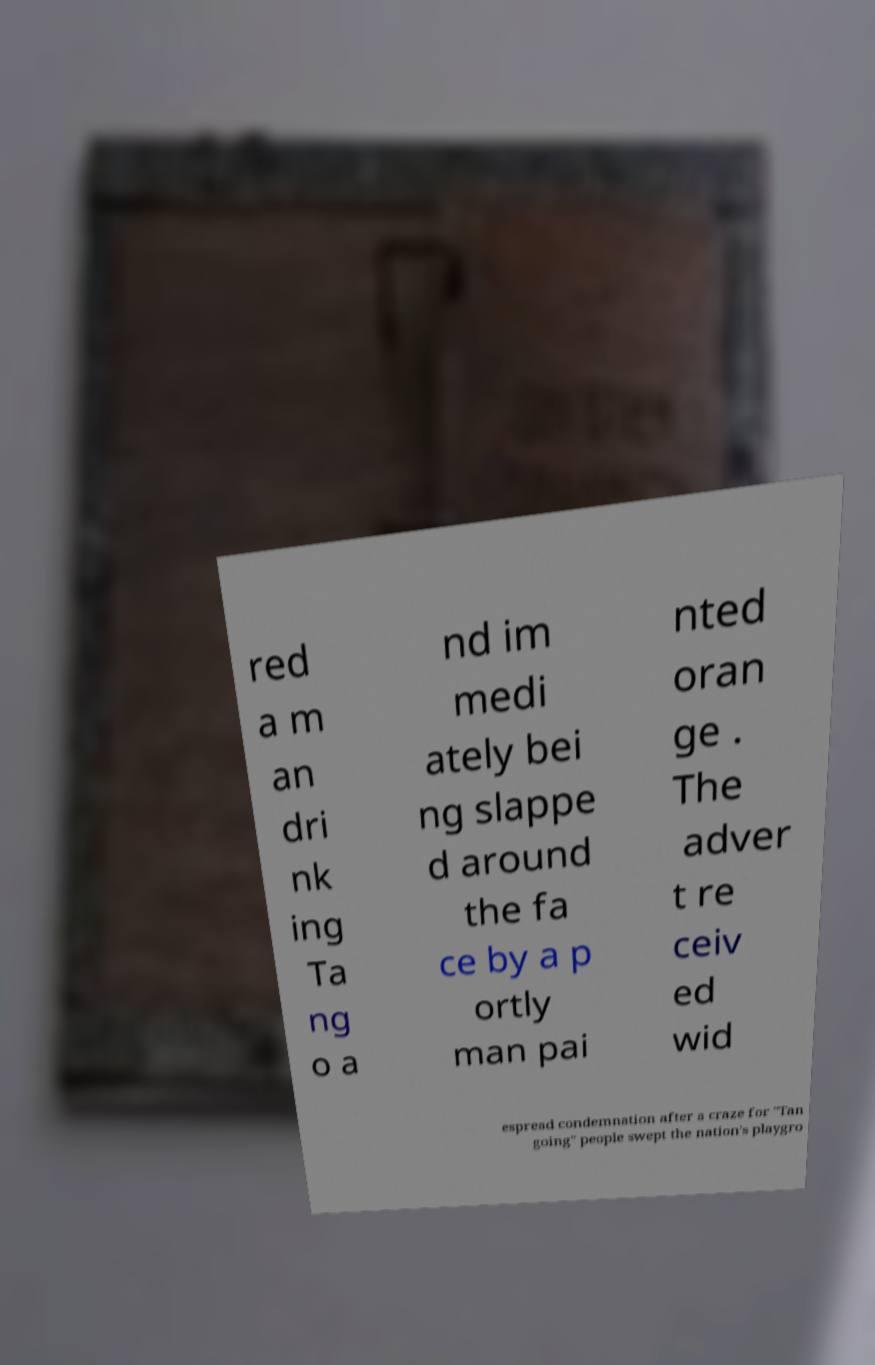Please identify and transcribe the text found in this image. red a m an dri nk ing Ta ng o a nd im medi ately bei ng slappe d around the fa ce by a p ortly man pai nted oran ge . The adver t re ceiv ed wid espread condemnation after a craze for "Tan going" people swept the nation's playgro 